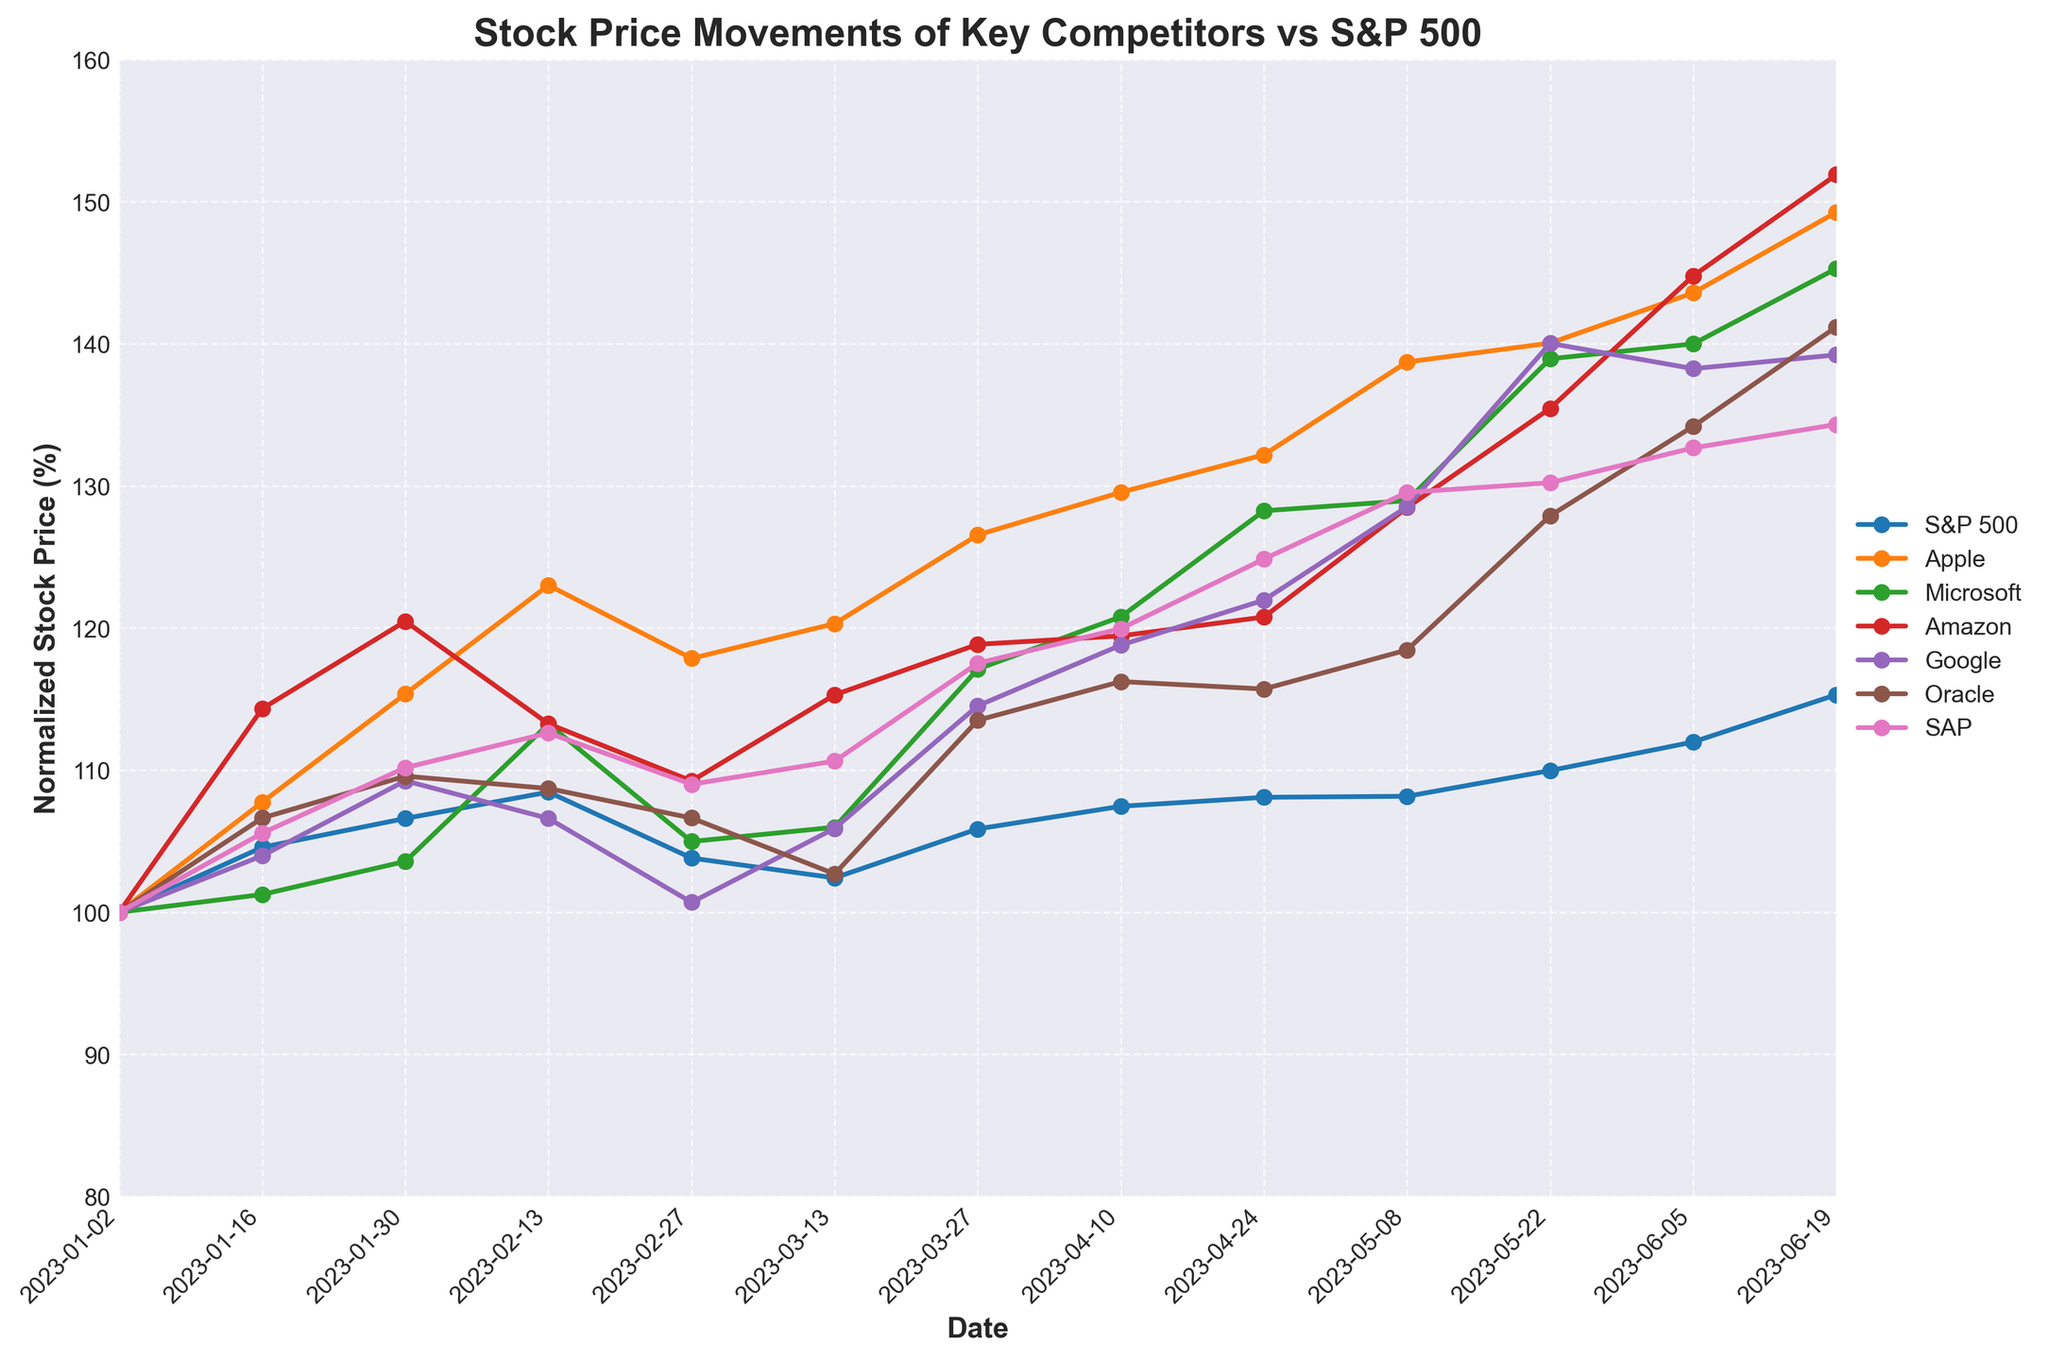Which company's stock increased the most in percentage terms over the 6 months? First trace the lines for each company from January to June. Identify the starting and ending points for each line in terms of percentage change. The company with the highest ending normalized value relative to its starting point has increased the most. SAP shows a significant rise from 100% to around 134%.
Answer: SAP How does Apple's stock price movement compare to Oracle's over the 6 months? Trace both Apple's and Oracle's lines from the start to the end of the period. Compare their overall trends and how they dip and rise relative to each other. Apple's stock shows a continual increase with minor dips, while Oracle's generally trends upward but with more fluctuation.
Answer: Apple rose more steadily than Oracle Which competitor's stock showed the least volatility over the period? Look for the line that shows the least fluctuation in its trajectory. Microsoft and Google show more stable lines compared to others. SAP and Amazon show more significant variability.
Answer: Microsoft/Google During which month did S&P 500 see the most significant increase? Trace the S&P 500 line and look for the steepest upward slope. January to early February shows a marked rise. The period starting from January 30 to February 13 appears to show the most significant increase.
Answer: Early February What is the percentage change in Amazon's stock price from the start to the end of the period? Identify Amazon's starting and ending normalized values. Starting at 100% and ending close to 135%. Calculate the percentage change using the formula \((Ending\ Value / Starting\ Value) * 100\% \). \( \frac{135-100}{100}*100\% = 35\% \)
Answer: 35% Compare the stock performance of S&P 500 and Google in March. Which one had a better performance? Check the lines for S&P 500 and Google in March. S&P 500 starts from around 100% to 107%, while Google starts at around 93% and ends at about 96%. S&P 500 increased more than Google in March.
Answer: S&P 500 Which stock shows a significant spike in the last two months? Look at the last two months (May and June) for each line. Identify any stock with a large slope increase. Microsoft's line shows a steep upward trend during this period.
Answer: Microsoft Was there a period when Oracle's stock price was below its starting value? Follow Oracle's line; it shows mostly upward trending with some fluctuations. Check if it ever dips below the 100% level of its initial value at the start of the chart. Oracle briefly moves below its starting value in mid-March.
Answer: Yes, mid-March Which stock had the highest percentage on June 19th? Find the values for each stock on the final date. Check which line reaches the highest normalized percentage. Microsoft shows the highest value, above 130%.
Answer: Microsoft 